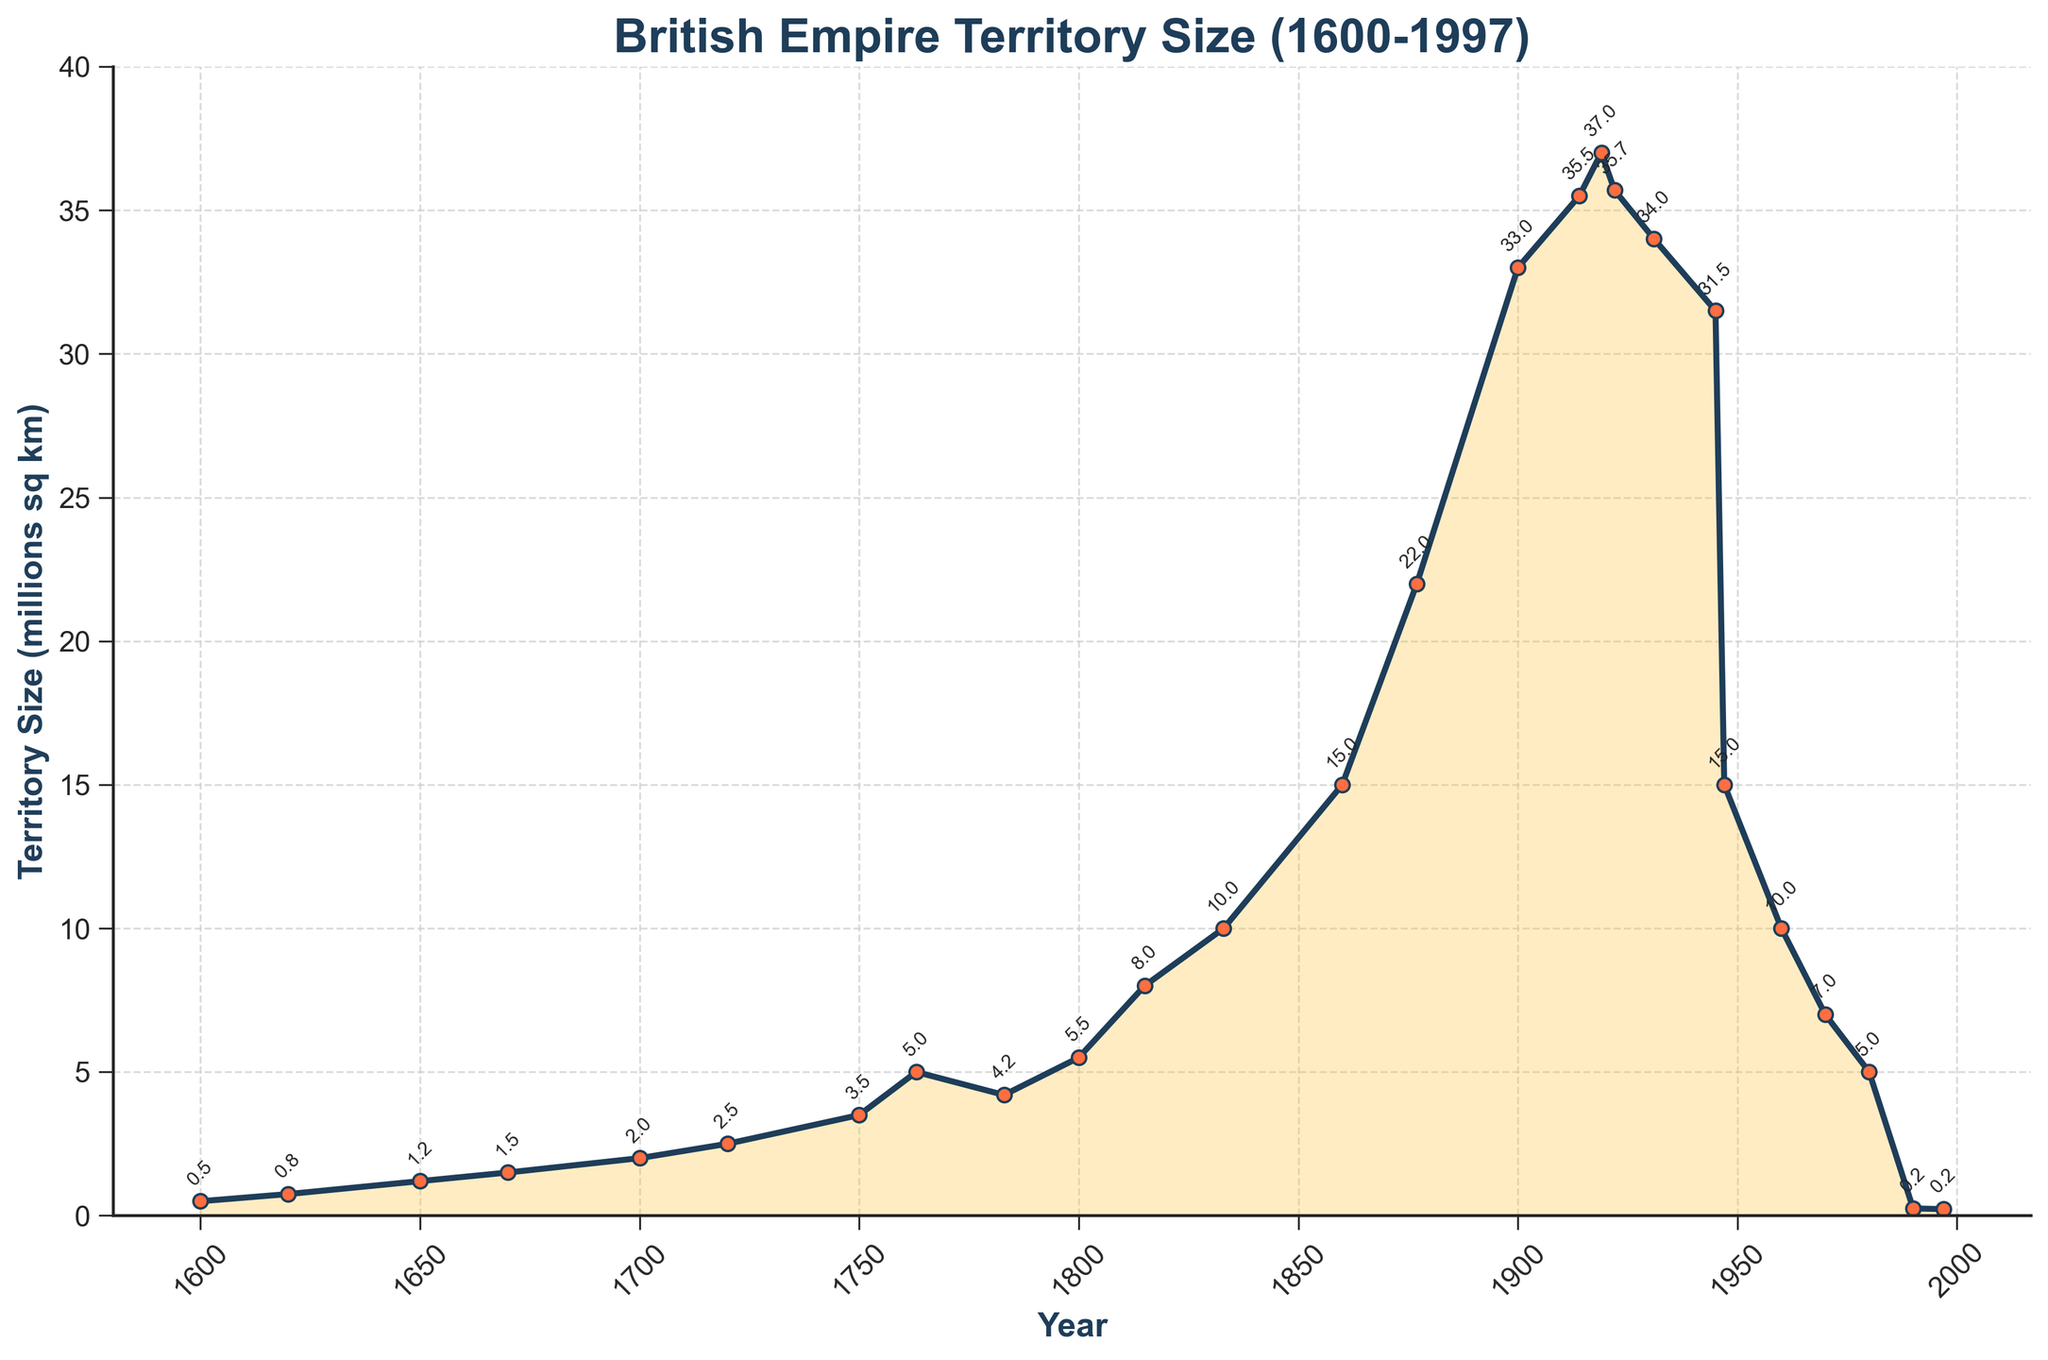Which year shows the maximum territorial size of the British Empire? To find the year with the maximum territorial size, look for the highest point on the line plot. The peak appears in 1922.
Answer: 1922 Between which years did the British Empire experience the most significant territorial loss? Identify the steepest downward slope in the plot. The largest decline occurs between 1945 and 1947.
Answer: 1945-1947 What was the territorial size of the British Empire in 1833 and how does it compare with the size in 1947? The plot shows the size in 1833 as approximately 10 million sq km and in 1947 as approximately 15 million sq km. Comparing the two, the Empire was 5 million sq km larger in 1947.
Answer: 5 million sq km larger in 1947 How many times did the territorial size of the British Empire triple between 1600 and 1922? In 1600, the size was 0.5 million sq km. Tripling would make it 1.5 million sq km. This size was achieved around 1670. Tripling again (to 4.5 million sq km) happens by 1763. Finally, another tripling (13.5 million sq km) is surpassed well before 1922, by 1860. So, it tripled three times.
Answer: 3 times What was the average territorial size of the British Empire from 1600 to 1700? Adding the sizes for 1600, 1620, 1650, 1670, and 1700: (0.5 + 0.75 + 1.2 + 1.5 + 2) million sq km. The total is 5.95 million sq km. Divide by 5 (number of years): 5.95 / 5 = 1.19 million sq km.
Answer: 1.19 million sq km Which period saw the most rapid expansion of the British Empire's territory size in terms of absolute increase? The steepest upward slopes indicate rapid expansions. Between 1860 and 1877, the size increases from 15 to 22 million sq km, an increase of 7 million sq km.
Answer: 1860-1877 What is the visual color used to annotate the territory size on the plot? Observing the annotations near data points, they are written in the same color as the main line, which is a dark shade.
Answer: Dark shade 